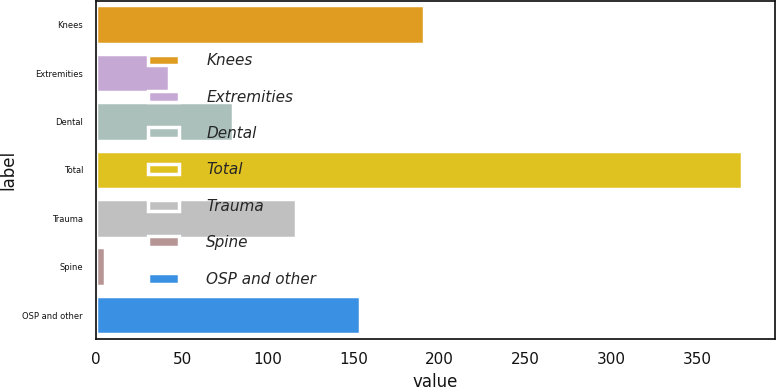<chart> <loc_0><loc_0><loc_500><loc_500><bar_chart><fcel>Knees<fcel>Extremities<fcel>Dental<fcel>Total<fcel>Trauma<fcel>Spine<fcel>OSP and other<nl><fcel>190.8<fcel>42.4<fcel>79.5<fcel>376.3<fcel>116.6<fcel>5.3<fcel>153.7<nl></chart> 